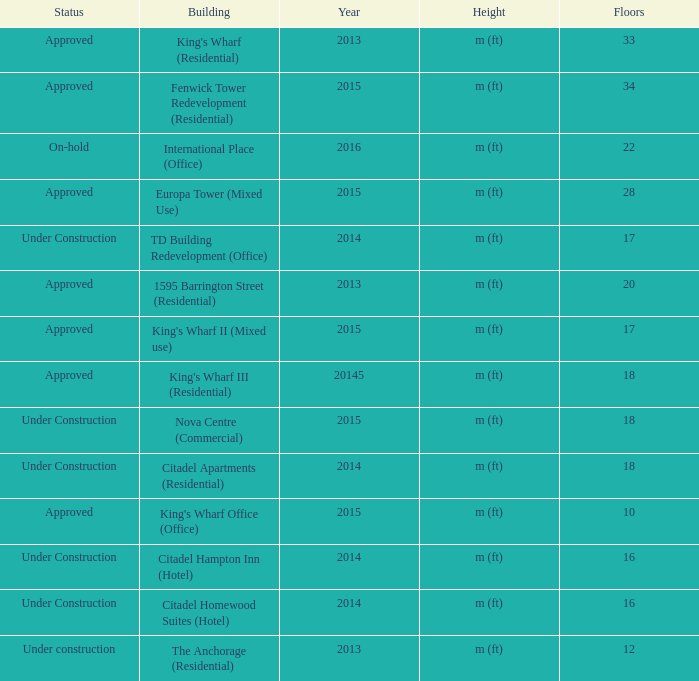What is the status of the building with more than 28 floor and a year of 2013? Approved. Parse the table in full. {'header': ['Status', 'Building', 'Year', 'Height', 'Floors'], 'rows': [['Approved', "King's Wharf (Residential)", '2013', 'm (ft)', '33'], ['Approved', 'Fenwick Tower Redevelopment (Residential)', '2015', 'm (ft)', '34'], ['On-hold', 'International Place (Office)', '2016', 'm (ft)', '22'], ['Approved', 'Europa Tower (Mixed Use)', '2015', 'm (ft)', '28'], ['Under Construction', 'TD Building Redevelopment (Office)', '2014', 'm (ft)', '17'], ['Approved', '1595 Barrington Street (Residential)', '2013', 'm (ft)', '20'], ['Approved', "King's Wharf II (Mixed use)", '2015', 'm (ft)', '17'], ['Approved', "King's Wharf III (Residential)", '20145', 'm (ft)', '18'], ['Under Construction', 'Nova Centre (Commercial)', '2015', 'm (ft)', '18'], ['Under Construction', 'Citadel Apartments (Residential)', '2014', 'm (ft)', '18'], ['Approved', "King's Wharf Office (Office)", '2015', 'm (ft)', '10'], ['Under Construction', 'Citadel Hampton Inn (Hotel)', '2014', 'm (ft)', '16'], ['Under Construction', 'Citadel Homewood Suites (Hotel)', '2014', 'm (ft)', '16'], ['Under construction', 'The Anchorage (Residential)', '2013', 'm (ft)', '12']]} 